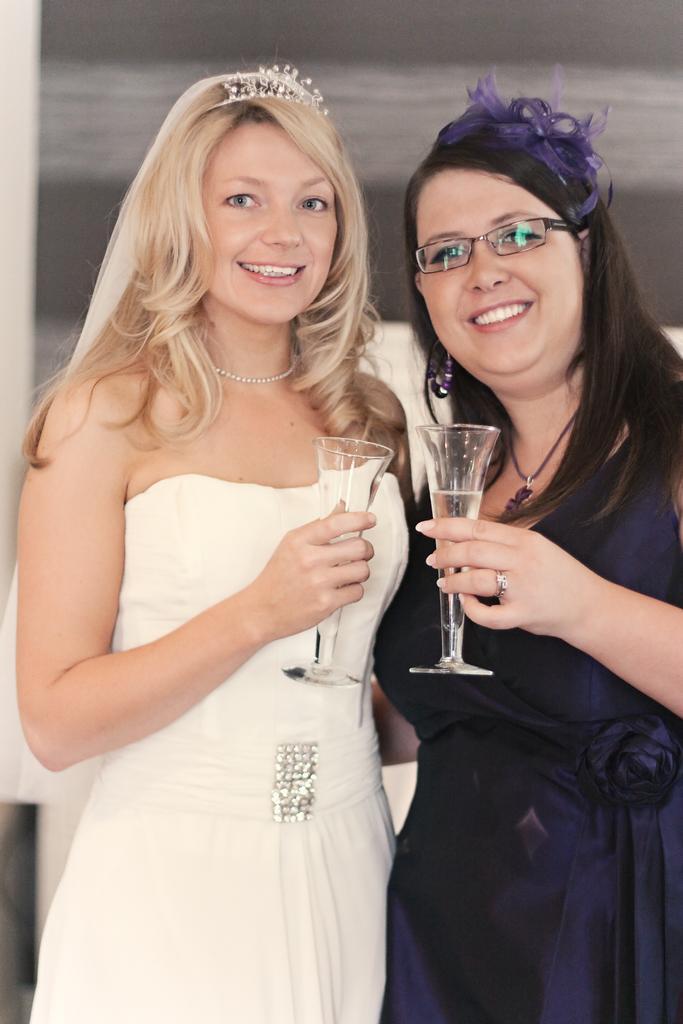Can you describe this image briefly? In this image there are 2 women standing and smiling by holding a glass , in the back ground there is a wall. 